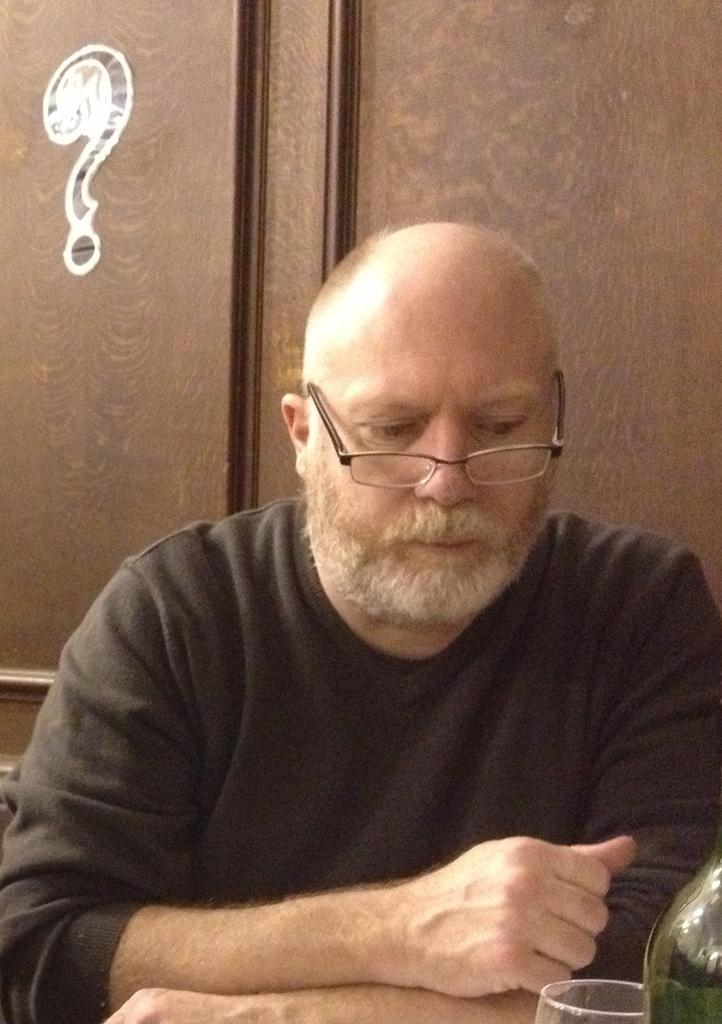What is the main subject of the image? There is a person in the image. What is the person doing in the image? The person is sitting. What is the person wearing in the image? The person is wearing a black shirt. What is a distinctive feature of the person's appearance? The person has a beard. What objects can be seen in the bottom right corner of the image? There is a bottle and a glass in the bottom right corner of the image. What type of dog is sitting next to the person in the image? There is no dog present in the image; only the person and the objects in the bottom right corner are visible. 